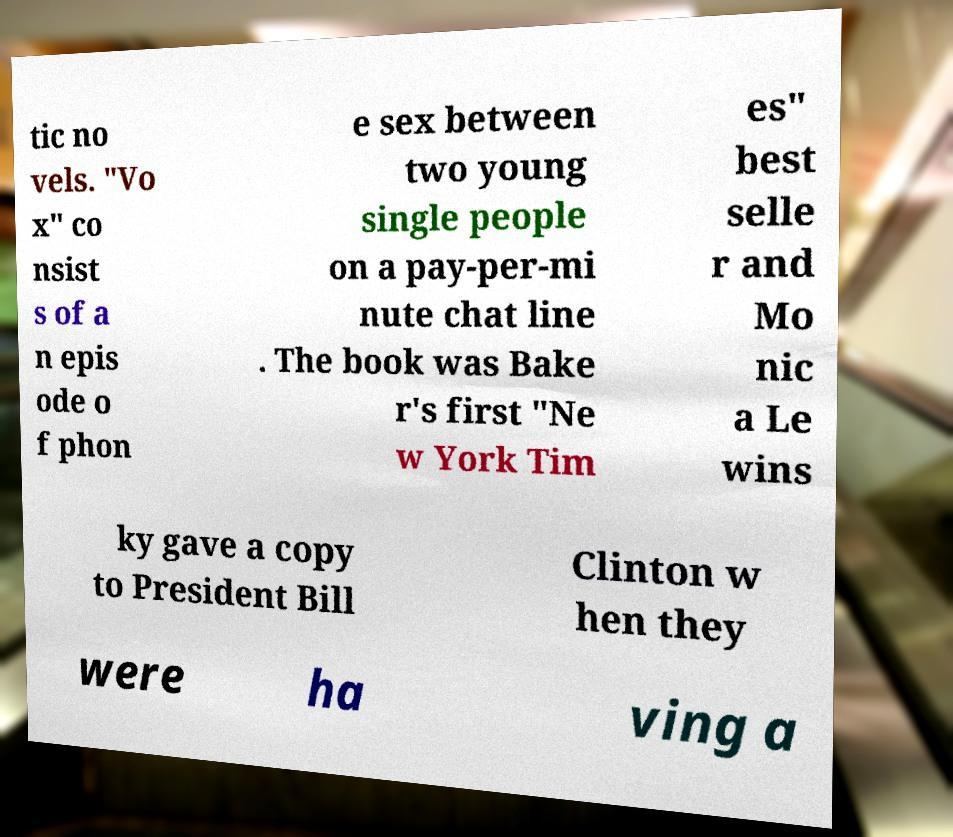Could you extract and type out the text from this image? tic no vels. "Vo x" co nsist s of a n epis ode o f phon e sex between two young single people on a pay-per-mi nute chat line . The book was Bake r's first "Ne w York Tim es" best selle r and Mo nic a Le wins ky gave a copy to President Bill Clinton w hen they were ha ving a 